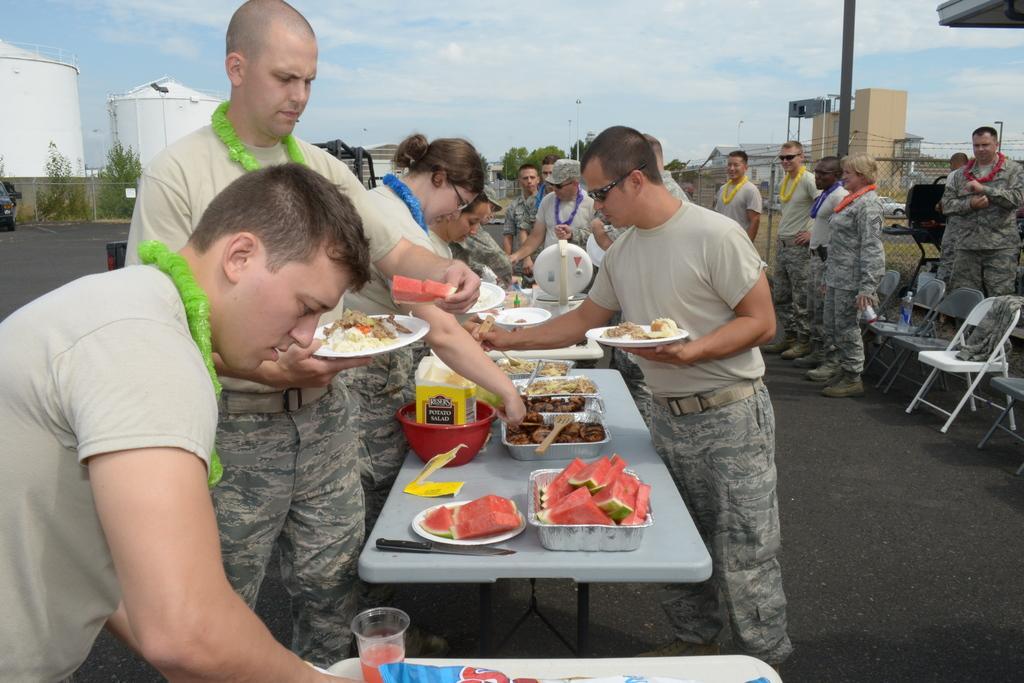Please provide a concise description of this image. In this image I can see people standing, wearing garlands and military uniform. There are food items on the tables. There are chairs on the right. There are trees, poles and other objects at the back. There is sky at the top. 